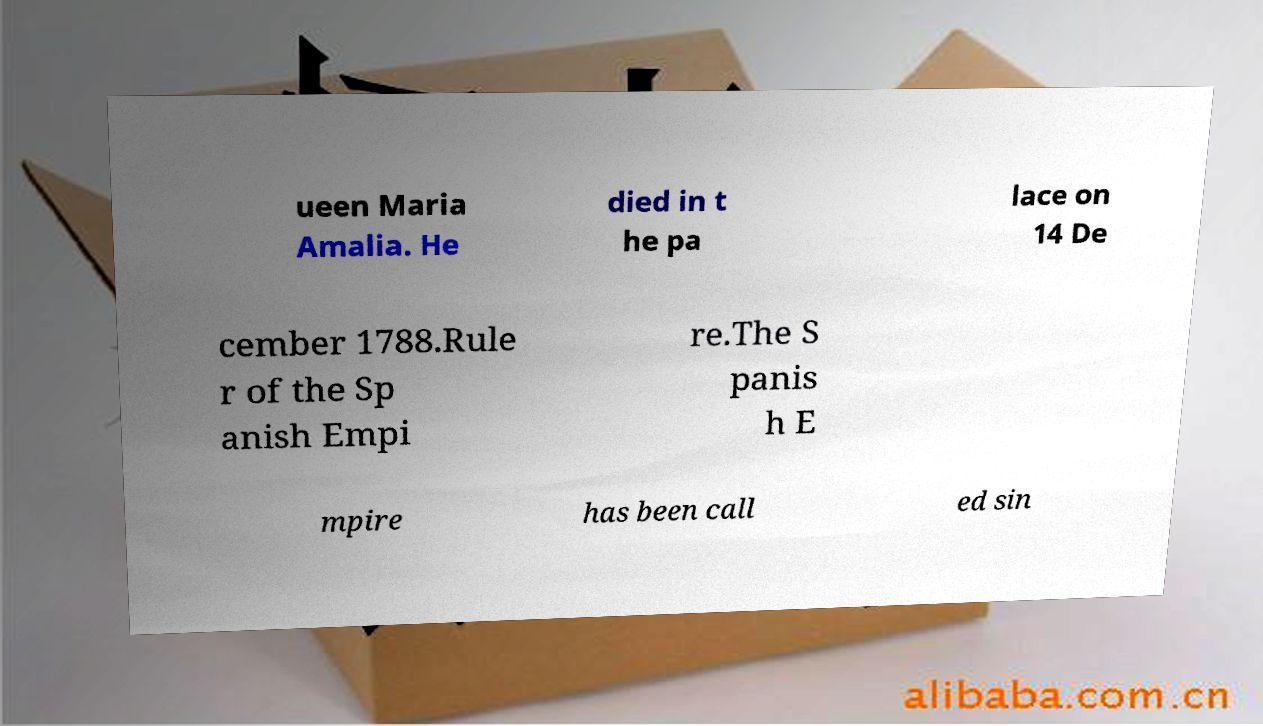What messages or text are displayed in this image? I need them in a readable, typed format. ueen Maria Amalia. He died in t he pa lace on 14 De cember 1788.Rule r of the Sp anish Empi re.The S panis h E mpire has been call ed sin 